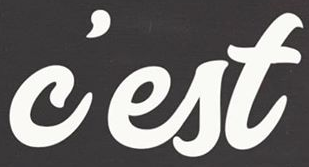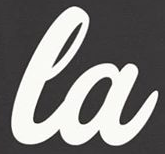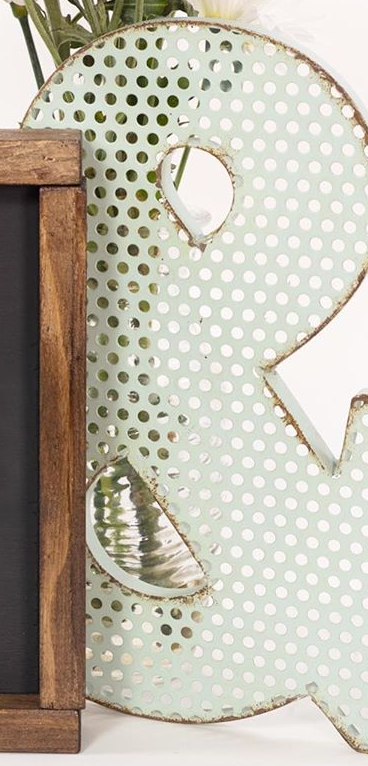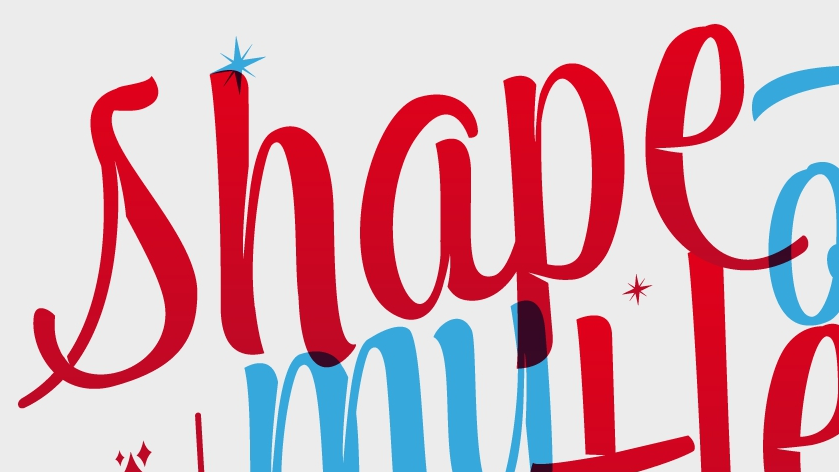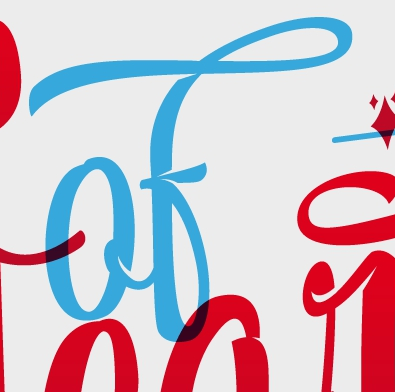What words can you see in these images in sequence, separated by a semicolon? c'est; la; &; shape; of 